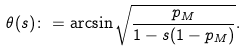Convert formula to latex. <formula><loc_0><loc_0><loc_500><loc_500>\theta ( s ) \colon = \arcsin \sqrt { \frac { p _ { M } } { 1 - s ( 1 - p _ { M } ) } } .</formula> 